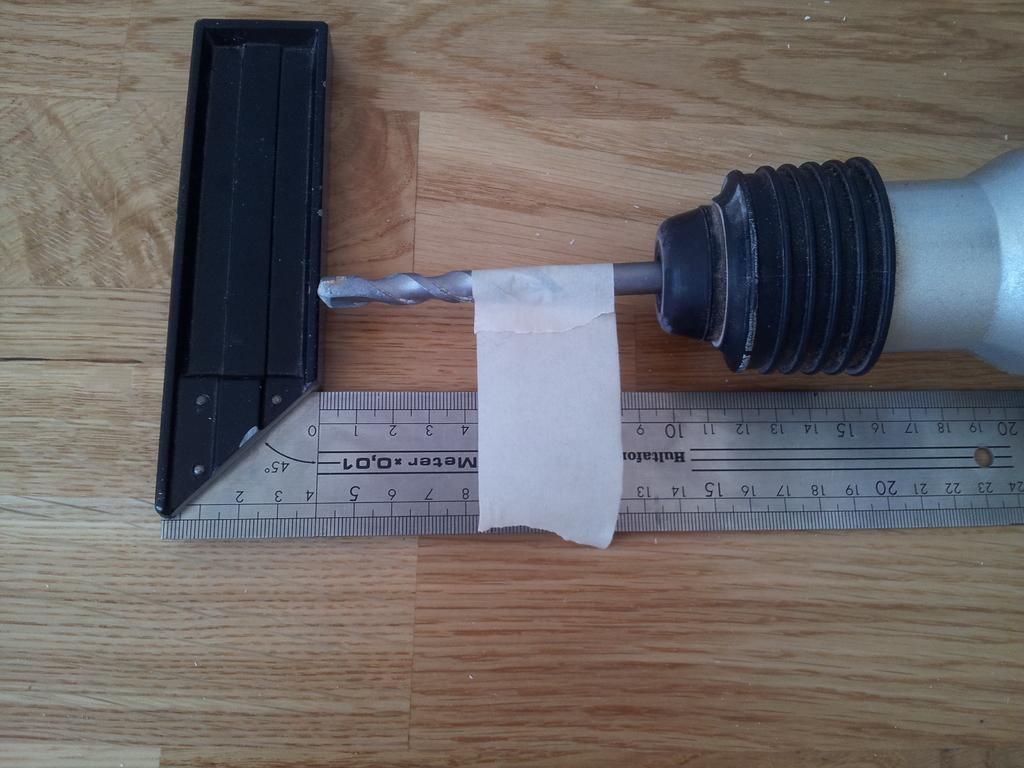<image>
Create a compact narrative representing the image presented. Tape is lined up close to the eight on a ruler. 